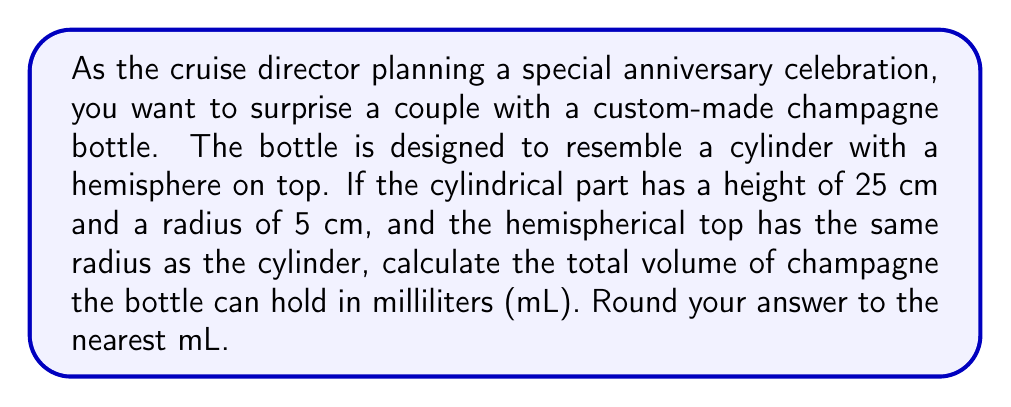Could you help me with this problem? To solve this problem, we need to calculate the volume of the cylinder and the hemisphere separately, then add them together.

1. Volume of the cylinder:
   The formula for the volume of a cylinder is $V_{cylinder} = \pi r^2 h$
   where $r$ is the radius and $h$ is the height.
   
   $V_{cylinder} = \pi \cdot (5\text{ cm})^2 \cdot 25\text{ cm}$
   $V_{cylinder} = 625\pi \text{ cm}^3$

2. Volume of the hemisphere:
   The formula for the volume of a hemisphere is $V_{hemisphere} = \frac{2}{3}\pi r^3$
   
   $V_{hemisphere} = \frac{2}{3}\pi \cdot (5\text{ cm})^3$
   $V_{hemisphere} = \frac{250}{3}\pi \text{ cm}^3$

3. Total volume:
   $V_{total} = V_{cylinder} + V_{hemisphere}$
   $V_{total} = 625\pi \text{ cm}^3 + \frac{250}{3}\pi \text{ cm}^3$
   $V_{total} = (625 + \frac{250}{3})\pi \text{ cm}^3$
   $V_{total} = \frac{2125}{3}\pi \text{ cm}^3$

4. Convert to milliliters:
   $1 \text{ cm}^3 = 1 \text{ mL}$, so we can directly convert our result:
   
   $V_{total} = \frac{2125}{3}\pi \text{ mL} \approx 2226.19 \text{ mL}$

5. Rounding to the nearest mL:
   $V_{total} \approx 2226 \text{ mL}$
Answer: $2226 \text{ mL}$ 